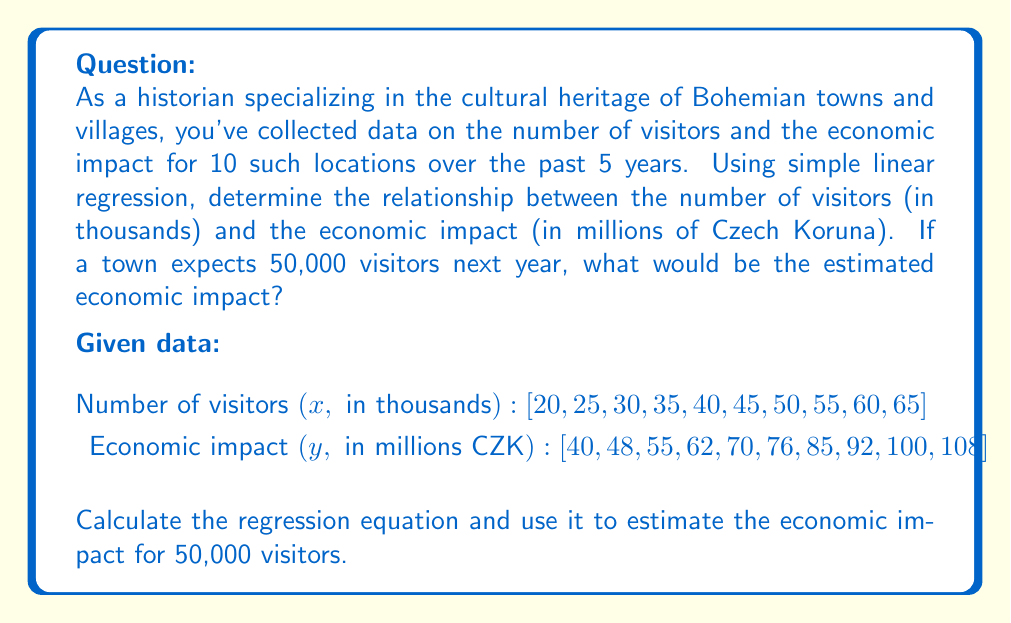Provide a solution to this math problem. To solve this problem, we'll use simple linear regression to find the relationship between the number of visitors and the economic impact. Then, we'll use the resulting equation to estimate the economic impact for 50,000 visitors.

Step 1: Calculate the means of x and y
$$\bar{x} = \frac{\sum x_i}{n} = \frac{425}{10} = 42.5$$
$$\bar{y} = \frac{\sum y_i}{n} = \frac{736}{10} = 73.6$$

Step 2: Calculate the slope (b) of the regression line
$$b = \frac{\sum (x_i - \bar{x})(y_i - \bar{y})}{\sum (x_i - \bar{x})^2}$$

To calculate this, we need to compute the following:
$$\sum (x_i - \bar{x})(y_i - \bar{y}) = 2,037.5$$
$$\sum (x_i - \bar{x})^2 = 1,312.5$$

Now we can calculate the slope:
$$b = \frac{2,037.5}{1,312.5} = 1.55$$

Step 3: Calculate the y-intercept (a)
$$a = \bar{y} - b\bar{x} = 73.6 - 1.55(42.5) = 7.725$$

Step 4: Write the regression equation
$$y = 1.55x + 7.725$$

Where y is the economic impact in millions of CZK and x is the number of visitors in thousands.

Step 5: Estimate the economic impact for 50,000 visitors
For 50,000 visitors, x = 50 (in thousands)

$$y = 1.55(50) + 7.725 = 85.225$$

Therefore, the estimated economic impact for 50,000 visitors is 85.225 million CZK.
Answer: The estimated economic impact for 50,000 visitors is 85.225 million Czech Koruna. 